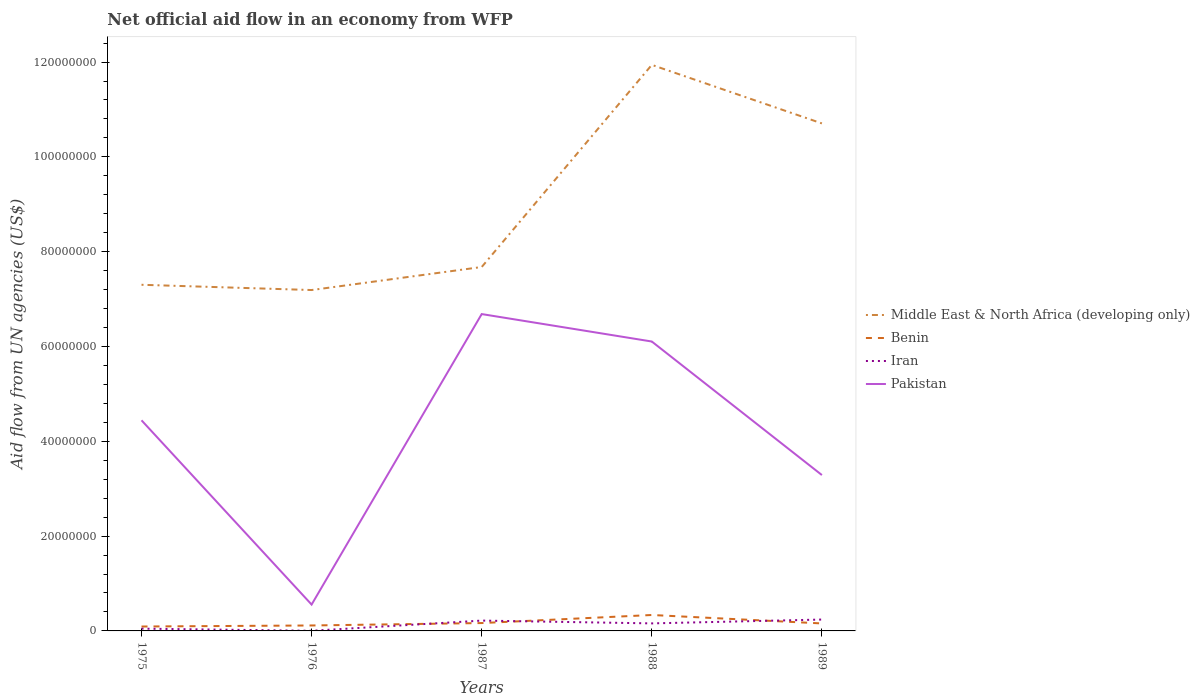How many different coloured lines are there?
Provide a short and direct response. 4. Does the line corresponding to Middle East & North Africa (developing only) intersect with the line corresponding to Pakistan?
Provide a succinct answer. No. Is the number of lines equal to the number of legend labels?
Your answer should be compact. Yes. Across all years, what is the maximum net official aid flow in Iran?
Offer a terse response. 3.00e+04. In which year was the net official aid flow in Iran maximum?
Give a very brief answer. 1976. What is the total net official aid flow in Middle East & North Africa (developing only) in the graph?
Offer a very short reply. -3.03e+07. What is the difference between the highest and the second highest net official aid flow in Pakistan?
Offer a terse response. 6.13e+07. How many lines are there?
Your answer should be very brief. 4. Are the values on the major ticks of Y-axis written in scientific E-notation?
Your answer should be very brief. No. How many legend labels are there?
Ensure brevity in your answer.  4. How are the legend labels stacked?
Give a very brief answer. Vertical. What is the title of the graph?
Your response must be concise. Net official aid flow in an economy from WFP. Does "Tunisia" appear as one of the legend labels in the graph?
Provide a succinct answer. No. What is the label or title of the Y-axis?
Offer a terse response. Aid flow from UN agencies (US$). What is the Aid flow from UN agencies (US$) in Middle East & North Africa (developing only) in 1975?
Offer a terse response. 7.30e+07. What is the Aid flow from UN agencies (US$) in Benin in 1975?
Your answer should be compact. 9.30e+05. What is the Aid flow from UN agencies (US$) of Pakistan in 1975?
Your response must be concise. 4.44e+07. What is the Aid flow from UN agencies (US$) in Middle East & North Africa (developing only) in 1976?
Keep it short and to the point. 7.19e+07. What is the Aid flow from UN agencies (US$) in Benin in 1976?
Provide a succinct answer. 1.15e+06. What is the Aid flow from UN agencies (US$) of Pakistan in 1976?
Your answer should be compact. 5.56e+06. What is the Aid flow from UN agencies (US$) of Middle East & North Africa (developing only) in 1987?
Provide a short and direct response. 7.68e+07. What is the Aid flow from UN agencies (US$) in Benin in 1987?
Ensure brevity in your answer.  1.66e+06. What is the Aid flow from UN agencies (US$) of Iran in 1987?
Give a very brief answer. 2.18e+06. What is the Aid flow from UN agencies (US$) in Pakistan in 1987?
Keep it short and to the point. 6.68e+07. What is the Aid flow from UN agencies (US$) of Middle East & North Africa (developing only) in 1988?
Provide a short and direct response. 1.19e+08. What is the Aid flow from UN agencies (US$) of Benin in 1988?
Provide a short and direct response. 3.36e+06. What is the Aid flow from UN agencies (US$) in Iran in 1988?
Your answer should be compact. 1.59e+06. What is the Aid flow from UN agencies (US$) in Pakistan in 1988?
Ensure brevity in your answer.  6.10e+07. What is the Aid flow from UN agencies (US$) in Middle East & North Africa (developing only) in 1989?
Keep it short and to the point. 1.07e+08. What is the Aid flow from UN agencies (US$) in Benin in 1989?
Offer a terse response. 1.58e+06. What is the Aid flow from UN agencies (US$) of Iran in 1989?
Give a very brief answer. 2.40e+06. What is the Aid flow from UN agencies (US$) in Pakistan in 1989?
Ensure brevity in your answer.  3.29e+07. Across all years, what is the maximum Aid flow from UN agencies (US$) in Middle East & North Africa (developing only)?
Keep it short and to the point. 1.19e+08. Across all years, what is the maximum Aid flow from UN agencies (US$) of Benin?
Make the answer very short. 3.36e+06. Across all years, what is the maximum Aid flow from UN agencies (US$) of Iran?
Give a very brief answer. 2.40e+06. Across all years, what is the maximum Aid flow from UN agencies (US$) in Pakistan?
Your answer should be very brief. 6.68e+07. Across all years, what is the minimum Aid flow from UN agencies (US$) of Middle East & North Africa (developing only)?
Provide a succinct answer. 7.19e+07. Across all years, what is the minimum Aid flow from UN agencies (US$) of Benin?
Your answer should be very brief. 9.30e+05. Across all years, what is the minimum Aid flow from UN agencies (US$) in Pakistan?
Your answer should be compact. 5.56e+06. What is the total Aid flow from UN agencies (US$) in Middle East & North Africa (developing only) in the graph?
Offer a very short reply. 4.48e+08. What is the total Aid flow from UN agencies (US$) of Benin in the graph?
Keep it short and to the point. 8.68e+06. What is the total Aid flow from UN agencies (US$) of Iran in the graph?
Give a very brief answer. 6.68e+06. What is the total Aid flow from UN agencies (US$) in Pakistan in the graph?
Keep it short and to the point. 2.11e+08. What is the difference between the Aid flow from UN agencies (US$) in Middle East & North Africa (developing only) in 1975 and that in 1976?
Your answer should be very brief. 1.11e+06. What is the difference between the Aid flow from UN agencies (US$) of Iran in 1975 and that in 1976?
Give a very brief answer. 4.50e+05. What is the difference between the Aid flow from UN agencies (US$) in Pakistan in 1975 and that in 1976?
Ensure brevity in your answer.  3.89e+07. What is the difference between the Aid flow from UN agencies (US$) in Middle East & North Africa (developing only) in 1975 and that in 1987?
Offer a terse response. -3.75e+06. What is the difference between the Aid flow from UN agencies (US$) in Benin in 1975 and that in 1987?
Your answer should be compact. -7.30e+05. What is the difference between the Aid flow from UN agencies (US$) of Iran in 1975 and that in 1987?
Ensure brevity in your answer.  -1.70e+06. What is the difference between the Aid flow from UN agencies (US$) of Pakistan in 1975 and that in 1987?
Give a very brief answer. -2.24e+07. What is the difference between the Aid flow from UN agencies (US$) in Middle East & North Africa (developing only) in 1975 and that in 1988?
Offer a very short reply. -4.64e+07. What is the difference between the Aid flow from UN agencies (US$) in Benin in 1975 and that in 1988?
Ensure brevity in your answer.  -2.43e+06. What is the difference between the Aid flow from UN agencies (US$) in Iran in 1975 and that in 1988?
Your answer should be very brief. -1.11e+06. What is the difference between the Aid flow from UN agencies (US$) in Pakistan in 1975 and that in 1988?
Provide a short and direct response. -1.66e+07. What is the difference between the Aid flow from UN agencies (US$) in Middle East & North Africa (developing only) in 1975 and that in 1989?
Give a very brief answer. -3.40e+07. What is the difference between the Aid flow from UN agencies (US$) in Benin in 1975 and that in 1989?
Ensure brevity in your answer.  -6.50e+05. What is the difference between the Aid flow from UN agencies (US$) of Iran in 1975 and that in 1989?
Keep it short and to the point. -1.92e+06. What is the difference between the Aid flow from UN agencies (US$) in Pakistan in 1975 and that in 1989?
Offer a very short reply. 1.16e+07. What is the difference between the Aid flow from UN agencies (US$) of Middle East & North Africa (developing only) in 1976 and that in 1987?
Your answer should be very brief. -4.86e+06. What is the difference between the Aid flow from UN agencies (US$) of Benin in 1976 and that in 1987?
Offer a very short reply. -5.10e+05. What is the difference between the Aid flow from UN agencies (US$) in Iran in 1976 and that in 1987?
Ensure brevity in your answer.  -2.15e+06. What is the difference between the Aid flow from UN agencies (US$) of Pakistan in 1976 and that in 1987?
Give a very brief answer. -6.13e+07. What is the difference between the Aid flow from UN agencies (US$) in Middle East & North Africa (developing only) in 1976 and that in 1988?
Offer a terse response. -4.75e+07. What is the difference between the Aid flow from UN agencies (US$) in Benin in 1976 and that in 1988?
Offer a very short reply. -2.21e+06. What is the difference between the Aid flow from UN agencies (US$) of Iran in 1976 and that in 1988?
Your answer should be compact. -1.56e+06. What is the difference between the Aid flow from UN agencies (US$) in Pakistan in 1976 and that in 1988?
Your answer should be very brief. -5.55e+07. What is the difference between the Aid flow from UN agencies (US$) of Middle East & North Africa (developing only) in 1976 and that in 1989?
Keep it short and to the point. -3.52e+07. What is the difference between the Aid flow from UN agencies (US$) in Benin in 1976 and that in 1989?
Ensure brevity in your answer.  -4.30e+05. What is the difference between the Aid flow from UN agencies (US$) of Iran in 1976 and that in 1989?
Ensure brevity in your answer.  -2.37e+06. What is the difference between the Aid flow from UN agencies (US$) in Pakistan in 1976 and that in 1989?
Your answer should be very brief. -2.73e+07. What is the difference between the Aid flow from UN agencies (US$) of Middle East & North Africa (developing only) in 1987 and that in 1988?
Your answer should be compact. -4.26e+07. What is the difference between the Aid flow from UN agencies (US$) in Benin in 1987 and that in 1988?
Give a very brief answer. -1.70e+06. What is the difference between the Aid flow from UN agencies (US$) of Iran in 1987 and that in 1988?
Give a very brief answer. 5.90e+05. What is the difference between the Aid flow from UN agencies (US$) in Pakistan in 1987 and that in 1988?
Provide a short and direct response. 5.79e+06. What is the difference between the Aid flow from UN agencies (US$) in Middle East & North Africa (developing only) in 1987 and that in 1989?
Give a very brief answer. -3.03e+07. What is the difference between the Aid flow from UN agencies (US$) of Benin in 1987 and that in 1989?
Ensure brevity in your answer.  8.00e+04. What is the difference between the Aid flow from UN agencies (US$) of Iran in 1987 and that in 1989?
Your answer should be compact. -2.20e+05. What is the difference between the Aid flow from UN agencies (US$) of Pakistan in 1987 and that in 1989?
Offer a very short reply. 3.40e+07. What is the difference between the Aid flow from UN agencies (US$) of Middle East & North Africa (developing only) in 1988 and that in 1989?
Provide a short and direct response. 1.24e+07. What is the difference between the Aid flow from UN agencies (US$) of Benin in 1988 and that in 1989?
Keep it short and to the point. 1.78e+06. What is the difference between the Aid flow from UN agencies (US$) of Iran in 1988 and that in 1989?
Offer a terse response. -8.10e+05. What is the difference between the Aid flow from UN agencies (US$) in Pakistan in 1988 and that in 1989?
Offer a very short reply. 2.82e+07. What is the difference between the Aid flow from UN agencies (US$) of Middle East & North Africa (developing only) in 1975 and the Aid flow from UN agencies (US$) of Benin in 1976?
Make the answer very short. 7.19e+07. What is the difference between the Aid flow from UN agencies (US$) in Middle East & North Africa (developing only) in 1975 and the Aid flow from UN agencies (US$) in Iran in 1976?
Offer a terse response. 7.30e+07. What is the difference between the Aid flow from UN agencies (US$) of Middle East & North Africa (developing only) in 1975 and the Aid flow from UN agencies (US$) of Pakistan in 1976?
Offer a terse response. 6.75e+07. What is the difference between the Aid flow from UN agencies (US$) in Benin in 1975 and the Aid flow from UN agencies (US$) in Pakistan in 1976?
Provide a short and direct response. -4.63e+06. What is the difference between the Aid flow from UN agencies (US$) of Iran in 1975 and the Aid flow from UN agencies (US$) of Pakistan in 1976?
Keep it short and to the point. -5.08e+06. What is the difference between the Aid flow from UN agencies (US$) in Middle East & North Africa (developing only) in 1975 and the Aid flow from UN agencies (US$) in Benin in 1987?
Give a very brief answer. 7.14e+07. What is the difference between the Aid flow from UN agencies (US$) of Middle East & North Africa (developing only) in 1975 and the Aid flow from UN agencies (US$) of Iran in 1987?
Offer a terse response. 7.08e+07. What is the difference between the Aid flow from UN agencies (US$) of Middle East & North Africa (developing only) in 1975 and the Aid flow from UN agencies (US$) of Pakistan in 1987?
Provide a succinct answer. 6.18e+06. What is the difference between the Aid flow from UN agencies (US$) of Benin in 1975 and the Aid flow from UN agencies (US$) of Iran in 1987?
Your response must be concise. -1.25e+06. What is the difference between the Aid flow from UN agencies (US$) in Benin in 1975 and the Aid flow from UN agencies (US$) in Pakistan in 1987?
Your answer should be compact. -6.59e+07. What is the difference between the Aid flow from UN agencies (US$) of Iran in 1975 and the Aid flow from UN agencies (US$) of Pakistan in 1987?
Offer a terse response. -6.64e+07. What is the difference between the Aid flow from UN agencies (US$) of Middle East & North Africa (developing only) in 1975 and the Aid flow from UN agencies (US$) of Benin in 1988?
Your answer should be very brief. 6.97e+07. What is the difference between the Aid flow from UN agencies (US$) in Middle East & North Africa (developing only) in 1975 and the Aid flow from UN agencies (US$) in Iran in 1988?
Give a very brief answer. 7.14e+07. What is the difference between the Aid flow from UN agencies (US$) in Middle East & North Africa (developing only) in 1975 and the Aid flow from UN agencies (US$) in Pakistan in 1988?
Your response must be concise. 1.20e+07. What is the difference between the Aid flow from UN agencies (US$) in Benin in 1975 and the Aid flow from UN agencies (US$) in Iran in 1988?
Provide a succinct answer. -6.60e+05. What is the difference between the Aid flow from UN agencies (US$) of Benin in 1975 and the Aid flow from UN agencies (US$) of Pakistan in 1988?
Give a very brief answer. -6.01e+07. What is the difference between the Aid flow from UN agencies (US$) of Iran in 1975 and the Aid flow from UN agencies (US$) of Pakistan in 1988?
Make the answer very short. -6.06e+07. What is the difference between the Aid flow from UN agencies (US$) in Middle East & North Africa (developing only) in 1975 and the Aid flow from UN agencies (US$) in Benin in 1989?
Offer a very short reply. 7.14e+07. What is the difference between the Aid flow from UN agencies (US$) in Middle East & North Africa (developing only) in 1975 and the Aid flow from UN agencies (US$) in Iran in 1989?
Your response must be concise. 7.06e+07. What is the difference between the Aid flow from UN agencies (US$) in Middle East & North Africa (developing only) in 1975 and the Aid flow from UN agencies (US$) in Pakistan in 1989?
Provide a short and direct response. 4.01e+07. What is the difference between the Aid flow from UN agencies (US$) in Benin in 1975 and the Aid flow from UN agencies (US$) in Iran in 1989?
Provide a short and direct response. -1.47e+06. What is the difference between the Aid flow from UN agencies (US$) of Benin in 1975 and the Aid flow from UN agencies (US$) of Pakistan in 1989?
Your answer should be compact. -3.20e+07. What is the difference between the Aid flow from UN agencies (US$) of Iran in 1975 and the Aid flow from UN agencies (US$) of Pakistan in 1989?
Ensure brevity in your answer.  -3.24e+07. What is the difference between the Aid flow from UN agencies (US$) of Middle East & North Africa (developing only) in 1976 and the Aid flow from UN agencies (US$) of Benin in 1987?
Offer a very short reply. 7.02e+07. What is the difference between the Aid flow from UN agencies (US$) of Middle East & North Africa (developing only) in 1976 and the Aid flow from UN agencies (US$) of Iran in 1987?
Offer a very short reply. 6.97e+07. What is the difference between the Aid flow from UN agencies (US$) of Middle East & North Africa (developing only) in 1976 and the Aid flow from UN agencies (US$) of Pakistan in 1987?
Your response must be concise. 5.07e+06. What is the difference between the Aid flow from UN agencies (US$) in Benin in 1976 and the Aid flow from UN agencies (US$) in Iran in 1987?
Your answer should be compact. -1.03e+06. What is the difference between the Aid flow from UN agencies (US$) in Benin in 1976 and the Aid flow from UN agencies (US$) in Pakistan in 1987?
Your response must be concise. -6.57e+07. What is the difference between the Aid flow from UN agencies (US$) of Iran in 1976 and the Aid flow from UN agencies (US$) of Pakistan in 1987?
Your answer should be compact. -6.68e+07. What is the difference between the Aid flow from UN agencies (US$) in Middle East & North Africa (developing only) in 1976 and the Aid flow from UN agencies (US$) in Benin in 1988?
Offer a very short reply. 6.86e+07. What is the difference between the Aid flow from UN agencies (US$) in Middle East & North Africa (developing only) in 1976 and the Aid flow from UN agencies (US$) in Iran in 1988?
Provide a succinct answer. 7.03e+07. What is the difference between the Aid flow from UN agencies (US$) of Middle East & North Africa (developing only) in 1976 and the Aid flow from UN agencies (US$) of Pakistan in 1988?
Offer a very short reply. 1.09e+07. What is the difference between the Aid flow from UN agencies (US$) of Benin in 1976 and the Aid flow from UN agencies (US$) of Iran in 1988?
Give a very brief answer. -4.40e+05. What is the difference between the Aid flow from UN agencies (US$) in Benin in 1976 and the Aid flow from UN agencies (US$) in Pakistan in 1988?
Your response must be concise. -5.99e+07. What is the difference between the Aid flow from UN agencies (US$) in Iran in 1976 and the Aid flow from UN agencies (US$) in Pakistan in 1988?
Make the answer very short. -6.10e+07. What is the difference between the Aid flow from UN agencies (US$) in Middle East & North Africa (developing only) in 1976 and the Aid flow from UN agencies (US$) in Benin in 1989?
Give a very brief answer. 7.03e+07. What is the difference between the Aid flow from UN agencies (US$) of Middle East & North Africa (developing only) in 1976 and the Aid flow from UN agencies (US$) of Iran in 1989?
Keep it short and to the point. 6.95e+07. What is the difference between the Aid flow from UN agencies (US$) in Middle East & North Africa (developing only) in 1976 and the Aid flow from UN agencies (US$) in Pakistan in 1989?
Ensure brevity in your answer.  3.90e+07. What is the difference between the Aid flow from UN agencies (US$) in Benin in 1976 and the Aid flow from UN agencies (US$) in Iran in 1989?
Provide a short and direct response. -1.25e+06. What is the difference between the Aid flow from UN agencies (US$) in Benin in 1976 and the Aid flow from UN agencies (US$) in Pakistan in 1989?
Keep it short and to the point. -3.17e+07. What is the difference between the Aid flow from UN agencies (US$) of Iran in 1976 and the Aid flow from UN agencies (US$) of Pakistan in 1989?
Your answer should be compact. -3.28e+07. What is the difference between the Aid flow from UN agencies (US$) of Middle East & North Africa (developing only) in 1987 and the Aid flow from UN agencies (US$) of Benin in 1988?
Keep it short and to the point. 7.34e+07. What is the difference between the Aid flow from UN agencies (US$) of Middle East & North Africa (developing only) in 1987 and the Aid flow from UN agencies (US$) of Iran in 1988?
Keep it short and to the point. 7.52e+07. What is the difference between the Aid flow from UN agencies (US$) in Middle East & North Africa (developing only) in 1987 and the Aid flow from UN agencies (US$) in Pakistan in 1988?
Your answer should be very brief. 1.57e+07. What is the difference between the Aid flow from UN agencies (US$) of Benin in 1987 and the Aid flow from UN agencies (US$) of Iran in 1988?
Your answer should be very brief. 7.00e+04. What is the difference between the Aid flow from UN agencies (US$) of Benin in 1987 and the Aid flow from UN agencies (US$) of Pakistan in 1988?
Offer a terse response. -5.94e+07. What is the difference between the Aid flow from UN agencies (US$) of Iran in 1987 and the Aid flow from UN agencies (US$) of Pakistan in 1988?
Make the answer very short. -5.89e+07. What is the difference between the Aid flow from UN agencies (US$) in Middle East & North Africa (developing only) in 1987 and the Aid flow from UN agencies (US$) in Benin in 1989?
Your response must be concise. 7.52e+07. What is the difference between the Aid flow from UN agencies (US$) of Middle East & North Africa (developing only) in 1987 and the Aid flow from UN agencies (US$) of Iran in 1989?
Provide a short and direct response. 7.44e+07. What is the difference between the Aid flow from UN agencies (US$) in Middle East & North Africa (developing only) in 1987 and the Aid flow from UN agencies (US$) in Pakistan in 1989?
Your response must be concise. 4.39e+07. What is the difference between the Aid flow from UN agencies (US$) in Benin in 1987 and the Aid flow from UN agencies (US$) in Iran in 1989?
Give a very brief answer. -7.40e+05. What is the difference between the Aid flow from UN agencies (US$) in Benin in 1987 and the Aid flow from UN agencies (US$) in Pakistan in 1989?
Your response must be concise. -3.12e+07. What is the difference between the Aid flow from UN agencies (US$) of Iran in 1987 and the Aid flow from UN agencies (US$) of Pakistan in 1989?
Ensure brevity in your answer.  -3.07e+07. What is the difference between the Aid flow from UN agencies (US$) in Middle East & North Africa (developing only) in 1988 and the Aid flow from UN agencies (US$) in Benin in 1989?
Keep it short and to the point. 1.18e+08. What is the difference between the Aid flow from UN agencies (US$) in Middle East & North Africa (developing only) in 1988 and the Aid flow from UN agencies (US$) in Iran in 1989?
Provide a succinct answer. 1.17e+08. What is the difference between the Aid flow from UN agencies (US$) of Middle East & North Africa (developing only) in 1988 and the Aid flow from UN agencies (US$) of Pakistan in 1989?
Ensure brevity in your answer.  8.65e+07. What is the difference between the Aid flow from UN agencies (US$) of Benin in 1988 and the Aid flow from UN agencies (US$) of Iran in 1989?
Give a very brief answer. 9.60e+05. What is the difference between the Aid flow from UN agencies (US$) in Benin in 1988 and the Aid flow from UN agencies (US$) in Pakistan in 1989?
Your answer should be very brief. -2.95e+07. What is the difference between the Aid flow from UN agencies (US$) of Iran in 1988 and the Aid flow from UN agencies (US$) of Pakistan in 1989?
Give a very brief answer. -3.13e+07. What is the average Aid flow from UN agencies (US$) of Middle East & North Africa (developing only) per year?
Your answer should be very brief. 8.96e+07. What is the average Aid flow from UN agencies (US$) in Benin per year?
Ensure brevity in your answer.  1.74e+06. What is the average Aid flow from UN agencies (US$) of Iran per year?
Offer a terse response. 1.34e+06. What is the average Aid flow from UN agencies (US$) in Pakistan per year?
Provide a succinct answer. 4.22e+07. In the year 1975, what is the difference between the Aid flow from UN agencies (US$) of Middle East & North Africa (developing only) and Aid flow from UN agencies (US$) of Benin?
Your response must be concise. 7.21e+07. In the year 1975, what is the difference between the Aid flow from UN agencies (US$) of Middle East & North Africa (developing only) and Aid flow from UN agencies (US$) of Iran?
Give a very brief answer. 7.25e+07. In the year 1975, what is the difference between the Aid flow from UN agencies (US$) in Middle East & North Africa (developing only) and Aid flow from UN agencies (US$) in Pakistan?
Offer a very short reply. 2.86e+07. In the year 1975, what is the difference between the Aid flow from UN agencies (US$) in Benin and Aid flow from UN agencies (US$) in Pakistan?
Provide a short and direct response. -4.35e+07. In the year 1975, what is the difference between the Aid flow from UN agencies (US$) of Iran and Aid flow from UN agencies (US$) of Pakistan?
Keep it short and to the point. -4.40e+07. In the year 1976, what is the difference between the Aid flow from UN agencies (US$) in Middle East & North Africa (developing only) and Aid flow from UN agencies (US$) in Benin?
Provide a short and direct response. 7.08e+07. In the year 1976, what is the difference between the Aid flow from UN agencies (US$) of Middle East & North Africa (developing only) and Aid flow from UN agencies (US$) of Iran?
Offer a terse response. 7.19e+07. In the year 1976, what is the difference between the Aid flow from UN agencies (US$) in Middle East & North Africa (developing only) and Aid flow from UN agencies (US$) in Pakistan?
Make the answer very short. 6.64e+07. In the year 1976, what is the difference between the Aid flow from UN agencies (US$) of Benin and Aid flow from UN agencies (US$) of Iran?
Give a very brief answer. 1.12e+06. In the year 1976, what is the difference between the Aid flow from UN agencies (US$) in Benin and Aid flow from UN agencies (US$) in Pakistan?
Your answer should be compact. -4.41e+06. In the year 1976, what is the difference between the Aid flow from UN agencies (US$) in Iran and Aid flow from UN agencies (US$) in Pakistan?
Give a very brief answer. -5.53e+06. In the year 1987, what is the difference between the Aid flow from UN agencies (US$) of Middle East & North Africa (developing only) and Aid flow from UN agencies (US$) of Benin?
Your answer should be very brief. 7.51e+07. In the year 1987, what is the difference between the Aid flow from UN agencies (US$) of Middle East & North Africa (developing only) and Aid flow from UN agencies (US$) of Iran?
Provide a succinct answer. 7.46e+07. In the year 1987, what is the difference between the Aid flow from UN agencies (US$) in Middle East & North Africa (developing only) and Aid flow from UN agencies (US$) in Pakistan?
Your response must be concise. 9.93e+06. In the year 1987, what is the difference between the Aid flow from UN agencies (US$) of Benin and Aid flow from UN agencies (US$) of Iran?
Provide a succinct answer. -5.20e+05. In the year 1987, what is the difference between the Aid flow from UN agencies (US$) of Benin and Aid flow from UN agencies (US$) of Pakistan?
Your answer should be very brief. -6.52e+07. In the year 1987, what is the difference between the Aid flow from UN agencies (US$) in Iran and Aid flow from UN agencies (US$) in Pakistan?
Offer a terse response. -6.47e+07. In the year 1988, what is the difference between the Aid flow from UN agencies (US$) in Middle East & North Africa (developing only) and Aid flow from UN agencies (US$) in Benin?
Provide a short and direct response. 1.16e+08. In the year 1988, what is the difference between the Aid flow from UN agencies (US$) of Middle East & North Africa (developing only) and Aid flow from UN agencies (US$) of Iran?
Provide a short and direct response. 1.18e+08. In the year 1988, what is the difference between the Aid flow from UN agencies (US$) in Middle East & North Africa (developing only) and Aid flow from UN agencies (US$) in Pakistan?
Keep it short and to the point. 5.84e+07. In the year 1988, what is the difference between the Aid flow from UN agencies (US$) of Benin and Aid flow from UN agencies (US$) of Iran?
Your answer should be very brief. 1.77e+06. In the year 1988, what is the difference between the Aid flow from UN agencies (US$) of Benin and Aid flow from UN agencies (US$) of Pakistan?
Provide a short and direct response. -5.77e+07. In the year 1988, what is the difference between the Aid flow from UN agencies (US$) of Iran and Aid flow from UN agencies (US$) of Pakistan?
Give a very brief answer. -5.95e+07. In the year 1989, what is the difference between the Aid flow from UN agencies (US$) in Middle East & North Africa (developing only) and Aid flow from UN agencies (US$) in Benin?
Make the answer very short. 1.05e+08. In the year 1989, what is the difference between the Aid flow from UN agencies (US$) in Middle East & North Africa (developing only) and Aid flow from UN agencies (US$) in Iran?
Your answer should be compact. 1.05e+08. In the year 1989, what is the difference between the Aid flow from UN agencies (US$) in Middle East & North Africa (developing only) and Aid flow from UN agencies (US$) in Pakistan?
Provide a short and direct response. 7.42e+07. In the year 1989, what is the difference between the Aid flow from UN agencies (US$) in Benin and Aid flow from UN agencies (US$) in Iran?
Keep it short and to the point. -8.20e+05. In the year 1989, what is the difference between the Aid flow from UN agencies (US$) of Benin and Aid flow from UN agencies (US$) of Pakistan?
Offer a very short reply. -3.13e+07. In the year 1989, what is the difference between the Aid flow from UN agencies (US$) of Iran and Aid flow from UN agencies (US$) of Pakistan?
Your response must be concise. -3.05e+07. What is the ratio of the Aid flow from UN agencies (US$) in Middle East & North Africa (developing only) in 1975 to that in 1976?
Keep it short and to the point. 1.02. What is the ratio of the Aid flow from UN agencies (US$) of Benin in 1975 to that in 1976?
Keep it short and to the point. 0.81. What is the ratio of the Aid flow from UN agencies (US$) in Iran in 1975 to that in 1976?
Offer a very short reply. 16. What is the ratio of the Aid flow from UN agencies (US$) of Pakistan in 1975 to that in 1976?
Offer a very short reply. 7.99. What is the ratio of the Aid flow from UN agencies (US$) of Middle East & North Africa (developing only) in 1975 to that in 1987?
Provide a short and direct response. 0.95. What is the ratio of the Aid flow from UN agencies (US$) of Benin in 1975 to that in 1987?
Offer a terse response. 0.56. What is the ratio of the Aid flow from UN agencies (US$) of Iran in 1975 to that in 1987?
Your answer should be very brief. 0.22. What is the ratio of the Aid flow from UN agencies (US$) of Pakistan in 1975 to that in 1987?
Your answer should be compact. 0.66. What is the ratio of the Aid flow from UN agencies (US$) of Middle East & North Africa (developing only) in 1975 to that in 1988?
Your answer should be very brief. 0.61. What is the ratio of the Aid flow from UN agencies (US$) of Benin in 1975 to that in 1988?
Make the answer very short. 0.28. What is the ratio of the Aid flow from UN agencies (US$) in Iran in 1975 to that in 1988?
Your answer should be very brief. 0.3. What is the ratio of the Aid flow from UN agencies (US$) in Pakistan in 1975 to that in 1988?
Your answer should be compact. 0.73. What is the ratio of the Aid flow from UN agencies (US$) of Middle East & North Africa (developing only) in 1975 to that in 1989?
Provide a short and direct response. 0.68. What is the ratio of the Aid flow from UN agencies (US$) of Benin in 1975 to that in 1989?
Ensure brevity in your answer.  0.59. What is the ratio of the Aid flow from UN agencies (US$) in Iran in 1975 to that in 1989?
Your answer should be very brief. 0.2. What is the ratio of the Aid flow from UN agencies (US$) in Pakistan in 1975 to that in 1989?
Your response must be concise. 1.35. What is the ratio of the Aid flow from UN agencies (US$) of Middle East & North Africa (developing only) in 1976 to that in 1987?
Your response must be concise. 0.94. What is the ratio of the Aid flow from UN agencies (US$) in Benin in 1976 to that in 1987?
Offer a very short reply. 0.69. What is the ratio of the Aid flow from UN agencies (US$) in Iran in 1976 to that in 1987?
Give a very brief answer. 0.01. What is the ratio of the Aid flow from UN agencies (US$) of Pakistan in 1976 to that in 1987?
Your answer should be very brief. 0.08. What is the ratio of the Aid flow from UN agencies (US$) in Middle East & North Africa (developing only) in 1976 to that in 1988?
Keep it short and to the point. 0.6. What is the ratio of the Aid flow from UN agencies (US$) of Benin in 1976 to that in 1988?
Offer a terse response. 0.34. What is the ratio of the Aid flow from UN agencies (US$) of Iran in 1976 to that in 1988?
Make the answer very short. 0.02. What is the ratio of the Aid flow from UN agencies (US$) of Pakistan in 1976 to that in 1988?
Keep it short and to the point. 0.09. What is the ratio of the Aid flow from UN agencies (US$) of Middle East & North Africa (developing only) in 1976 to that in 1989?
Ensure brevity in your answer.  0.67. What is the ratio of the Aid flow from UN agencies (US$) of Benin in 1976 to that in 1989?
Offer a very short reply. 0.73. What is the ratio of the Aid flow from UN agencies (US$) of Iran in 1976 to that in 1989?
Ensure brevity in your answer.  0.01. What is the ratio of the Aid flow from UN agencies (US$) of Pakistan in 1976 to that in 1989?
Your response must be concise. 0.17. What is the ratio of the Aid flow from UN agencies (US$) in Middle East & North Africa (developing only) in 1987 to that in 1988?
Give a very brief answer. 0.64. What is the ratio of the Aid flow from UN agencies (US$) in Benin in 1987 to that in 1988?
Your answer should be very brief. 0.49. What is the ratio of the Aid flow from UN agencies (US$) in Iran in 1987 to that in 1988?
Your answer should be very brief. 1.37. What is the ratio of the Aid flow from UN agencies (US$) in Pakistan in 1987 to that in 1988?
Ensure brevity in your answer.  1.09. What is the ratio of the Aid flow from UN agencies (US$) of Middle East & North Africa (developing only) in 1987 to that in 1989?
Ensure brevity in your answer.  0.72. What is the ratio of the Aid flow from UN agencies (US$) of Benin in 1987 to that in 1989?
Give a very brief answer. 1.05. What is the ratio of the Aid flow from UN agencies (US$) of Iran in 1987 to that in 1989?
Offer a very short reply. 0.91. What is the ratio of the Aid flow from UN agencies (US$) in Pakistan in 1987 to that in 1989?
Your answer should be compact. 2.03. What is the ratio of the Aid flow from UN agencies (US$) of Middle East & North Africa (developing only) in 1988 to that in 1989?
Give a very brief answer. 1.12. What is the ratio of the Aid flow from UN agencies (US$) in Benin in 1988 to that in 1989?
Your answer should be compact. 2.13. What is the ratio of the Aid flow from UN agencies (US$) in Iran in 1988 to that in 1989?
Your answer should be compact. 0.66. What is the ratio of the Aid flow from UN agencies (US$) of Pakistan in 1988 to that in 1989?
Keep it short and to the point. 1.86. What is the difference between the highest and the second highest Aid flow from UN agencies (US$) of Middle East & North Africa (developing only)?
Keep it short and to the point. 1.24e+07. What is the difference between the highest and the second highest Aid flow from UN agencies (US$) in Benin?
Give a very brief answer. 1.70e+06. What is the difference between the highest and the second highest Aid flow from UN agencies (US$) in Iran?
Your answer should be very brief. 2.20e+05. What is the difference between the highest and the second highest Aid flow from UN agencies (US$) in Pakistan?
Make the answer very short. 5.79e+06. What is the difference between the highest and the lowest Aid flow from UN agencies (US$) in Middle East & North Africa (developing only)?
Make the answer very short. 4.75e+07. What is the difference between the highest and the lowest Aid flow from UN agencies (US$) in Benin?
Your answer should be compact. 2.43e+06. What is the difference between the highest and the lowest Aid flow from UN agencies (US$) of Iran?
Offer a very short reply. 2.37e+06. What is the difference between the highest and the lowest Aid flow from UN agencies (US$) of Pakistan?
Keep it short and to the point. 6.13e+07. 